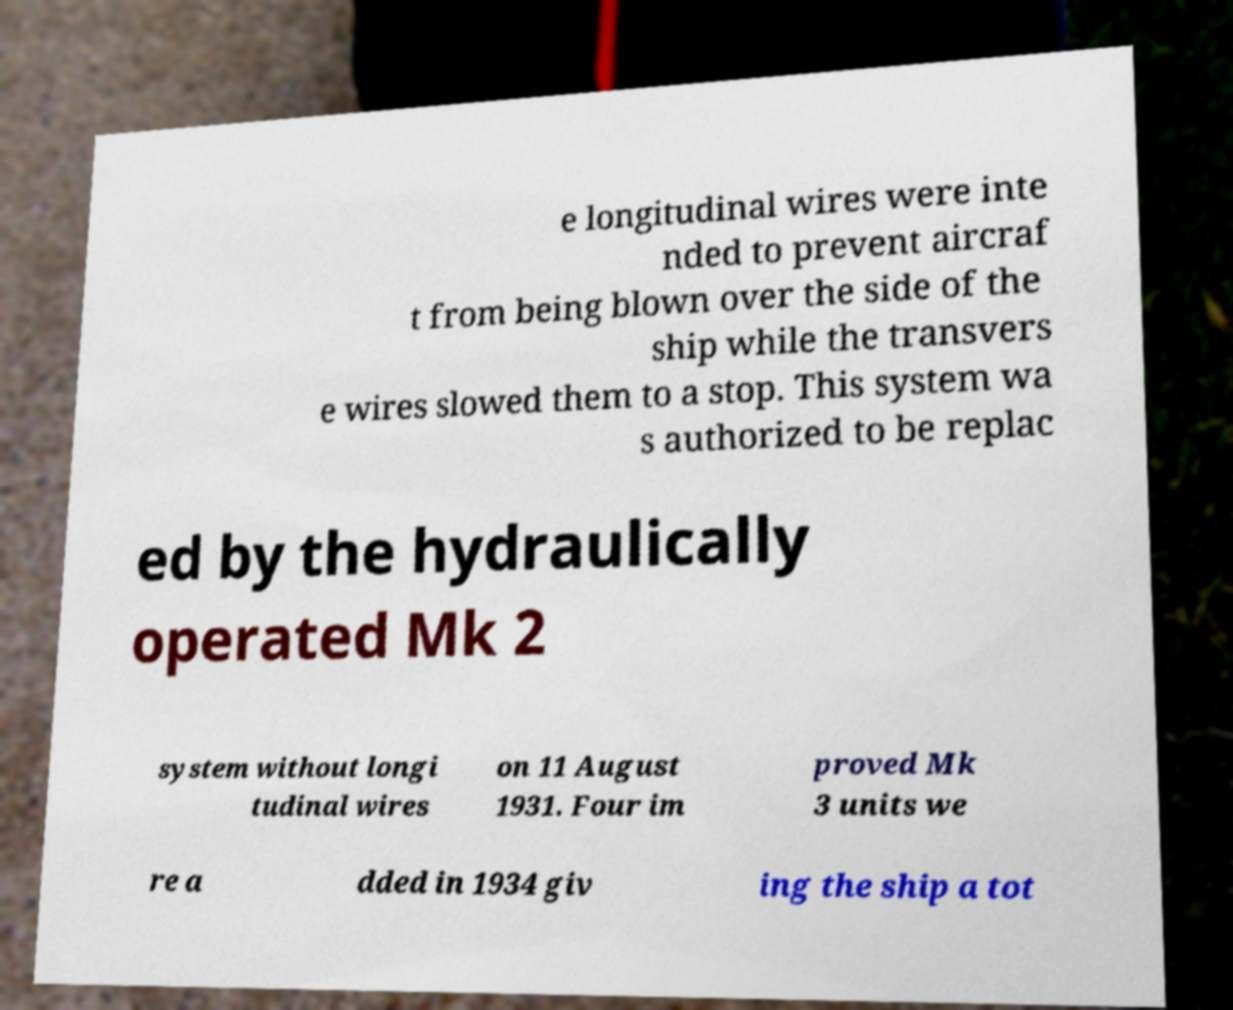Can you read and provide the text displayed in the image?This photo seems to have some interesting text. Can you extract and type it out for me? e longitudinal wires were inte nded to prevent aircraf t from being blown over the side of the ship while the transvers e wires slowed them to a stop. This system wa s authorized to be replac ed by the hydraulically operated Mk 2 system without longi tudinal wires on 11 August 1931. Four im proved Mk 3 units we re a dded in 1934 giv ing the ship a tot 